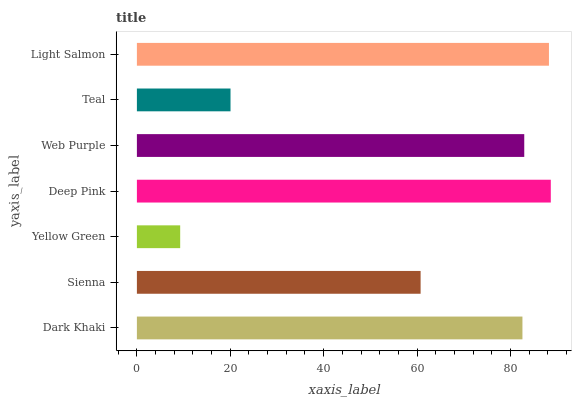Is Yellow Green the minimum?
Answer yes or no. Yes. Is Deep Pink the maximum?
Answer yes or no. Yes. Is Sienna the minimum?
Answer yes or no. No. Is Sienna the maximum?
Answer yes or no. No. Is Dark Khaki greater than Sienna?
Answer yes or no. Yes. Is Sienna less than Dark Khaki?
Answer yes or no. Yes. Is Sienna greater than Dark Khaki?
Answer yes or no. No. Is Dark Khaki less than Sienna?
Answer yes or no. No. Is Dark Khaki the high median?
Answer yes or no. Yes. Is Dark Khaki the low median?
Answer yes or no. Yes. Is Yellow Green the high median?
Answer yes or no. No. Is Deep Pink the low median?
Answer yes or no. No. 